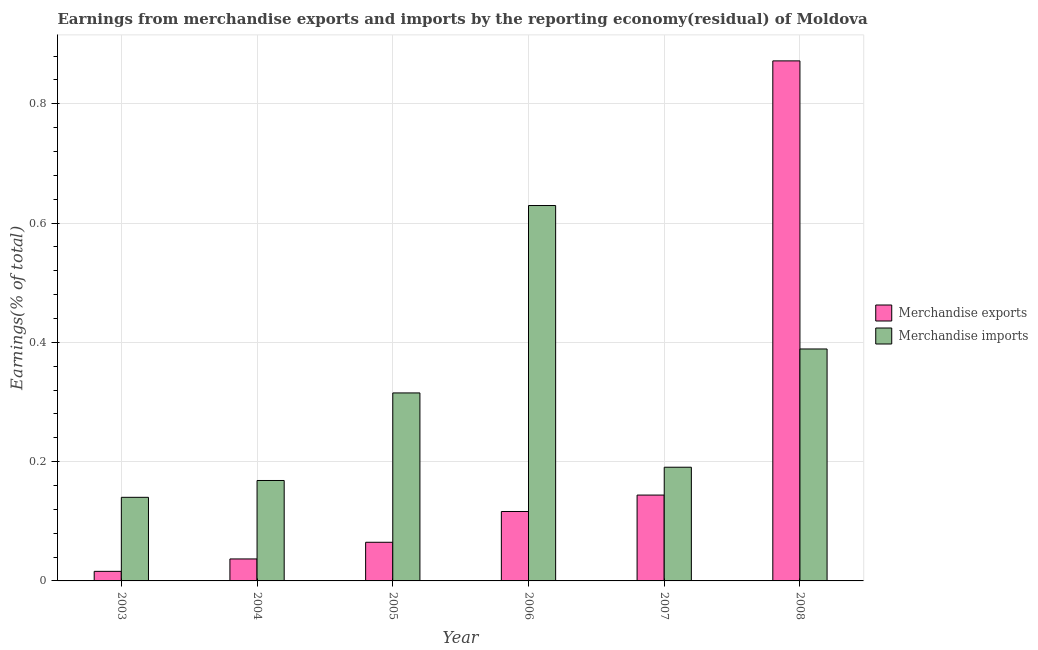Are the number of bars per tick equal to the number of legend labels?
Ensure brevity in your answer.  Yes. Are the number of bars on each tick of the X-axis equal?
Your response must be concise. Yes. What is the label of the 5th group of bars from the left?
Provide a short and direct response. 2007. In how many cases, is the number of bars for a given year not equal to the number of legend labels?
Offer a very short reply. 0. What is the earnings from merchandise imports in 2008?
Offer a very short reply. 0.39. Across all years, what is the maximum earnings from merchandise exports?
Offer a very short reply. 0.87. Across all years, what is the minimum earnings from merchandise imports?
Ensure brevity in your answer.  0.14. What is the total earnings from merchandise imports in the graph?
Provide a succinct answer. 1.83. What is the difference between the earnings from merchandise exports in 2004 and that in 2007?
Provide a short and direct response. -0.11. What is the difference between the earnings from merchandise exports in 2004 and the earnings from merchandise imports in 2008?
Your answer should be very brief. -0.84. What is the average earnings from merchandise exports per year?
Your answer should be compact. 0.21. In how many years, is the earnings from merchandise exports greater than 0.7200000000000001 %?
Make the answer very short. 1. What is the ratio of the earnings from merchandise exports in 2003 to that in 2007?
Ensure brevity in your answer.  0.11. Is the earnings from merchandise exports in 2004 less than that in 2008?
Your response must be concise. Yes. Is the difference between the earnings from merchandise imports in 2005 and 2007 greater than the difference between the earnings from merchandise exports in 2005 and 2007?
Your response must be concise. No. What is the difference between the highest and the second highest earnings from merchandise exports?
Give a very brief answer. 0.73. What is the difference between the highest and the lowest earnings from merchandise imports?
Offer a very short reply. 0.49. In how many years, is the earnings from merchandise exports greater than the average earnings from merchandise exports taken over all years?
Your answer should be very brief. 1. How many bars are there?
Provide a short and direct response. 12. Are all the bars in the graph horizontal?
Your answer should be compact. No. Are the values on the major ticks of Y-axis written in scientific E-notation?
Provide a succinct answer. No. Does the graph contain any zero values?
Make the answer very short. No. Does the graph contain grids?
Your answer should be very brief. Yes. Where does the legend appear in the graph?
Your response must be concise. Center right. What is the title of the graph?
Make the answer very short. Earnings from merchandise exports and imports by the reporting economy(residual) of Moldova. Does "Researchers" appear as one of the legend labels in the graph?
Keep it short and to the point. No. What is the label or title of the Y-axis?
Make the answer very short. Earnings(% of total). What is the Earnings(% of total) in Merchandise exports in 2003?
Offer a terse response. 0.02. What is the Earnings(% of total) of Merchandise imports in 2003?
Provide a short and direct response. 0.14. What is the Earnings(% of total) in Merchandise exports in 2004?
Provide a short and direct response. 0.04. What is the Earnings(% of total) in Merchandise imports in 2004?
Your answer should be compact. 0.17. What is the Earnings(% of total) in Merchandise exports in 2005?
Provide a succinct answer. 0.06. What is the Earnings(% of total) in Merchandise imports in 2005?
Offer a very short reply. 0.32. What is the Earnings(% of total) in Merchandise exports in 2006?
Keep it short and to the point. 0.12. What is the Earnings(% of total) in Merchandise imports in 2006?
Provide a succinct answer. 0.63. What is the Earnings(% of total) of Merchandise exports in 2007?
Your answer should be very brief. 0.14. What is the Earnings(% of total) of Merchandise imports in 2007?
Offer a terse response. 0.19. What is the Earnings(% of total) in Merchandise exports in 2008?
Make the answer very short. 0.87. What is the Earnings(% of total) in Merchandise imports in 2008?
Make the answer very short. 0.39. Across all years, what is the maximum Earnings(% of total) in Merchandise exports?
Keep it short and to the point. 0.87. Across all years, what is the maximum Earnings(% of total) of Merchandise imports?
Your response must be concise. 0.63. Across all years, what is the minimum Earnings(% of total) in Merchandise exports?
Provide a short and direct response. 0.02. Across all years, what is the minimum Earnings(% of total) of Merchandise imports?
Offer a very short reply. 0.14. What is the total Earnings(% of total) of Merchandise exports in the graph?
Offer a very short reply. 1.25. What is the total Earnings(% of total) of Merchandise imports in the graph?
Your response must be concise. 1.83. What is the difference between the Earnings(% of total) of Merchandise exports in 2003 and that in 2004?
Provide a succinct answer. -0.02. What is the difference between the Earnings(% of total) of Merchandise imports in 2003 and that in 2004?
Give a very brief answer. -0.03. What is the difference between the Earnings(% of total) of Merchandise exports in 2003 and that in 2005?
Your response must be concise. -0.05. What is the difference between the Earnings(% of total) of Merchandise imports in 2003 and that in 2005?
Offer a very short reply. -0.17. What is the difference between the Earnings(% of total) in Merchandise exports in 2003 and that in 2006?
Provide a succinct answer. -0.1. What is the difference between the Earnings(% of total) of Merchandise imports in 2003 and that in 2006?
Keep it short and to the point. -0.49. What is the difference between the Earnings(% of total) in Merchandise exports in 2003 and that in 2007?
Provide a short and direct response. -0.13. What is the difference between the Earnings(% of total) in Merchandise imports in 2003 and that in 2007?
Give a very brief answer. -0.05. What is the difference between the Earnings(% of total) in Merchandise exports in 2003 and that in 2008?
Provide a short and direct response. -0.86. What is the difference between the Earnings(% of total) of Merchandise imports in 2003 and that in 2008?
Your response must be concise. -0.25. What is the difference between the Earnings(% of total) in Merchandise exports in 2004 and that in 2005?
Provide a short and direct response. -0.03. What is the difference between the Earnings(% of total) of Merchandise imports in 2004 and that in 2005?
Provide a succinct answer. -0.15. What is the difference between the Earnings(% of total) in Merchandise exports in 2004 and that in 2006?
Make the answer very short. -0.08. What is the difference between the Earnings(% of total) of Merchandise imports in 2004 and that in 2006?
Make the answer very short. -0.46. What is the difference between the Earnings(% of total) in Merchandise exports in 2004 and that in 2007?
Give a very brief answer. -0.11. What is the difference between the Earnings(% of total) of Merchandise imports in 2004 and that in 2007?
Make the answer very short. -0.02. What is the difference between the Earnings(% of total) in Merchandise exports in 2004 and that in 2008?
Your response must be concise. -0.84. What is the difference between the Earnings(% of total) in Merchandise imports in 2004 and that in 2008?
Offer a very short reply. -0.22. What is the difference between the Earnings(% of total) in Merchandise exports in 2005 and that in 2006?
Provide a short and direct response. -0.05. What is the difference between the Earnings(% of total) in Merchandise imports in 2005 and that in 2006?
Give a very brief answer. -0.31. What is the difference between the Earnings(% of total) of Merchandise exports in 2005 and that in 2007?
Provide a short and direct response. -0.08. What is the difference between the Earnings(% of total) of Merchandise imports in 2005 and that in 2007?
Your answer should be very brief. 0.12. What is the difference between the Earnings(% of total) of Merchandise exports in 2005 and that in 2008?
Ensure brevity in your answer.  -0.81. What is the difference between the Earnings(% of total) in Merchandise imports in 2005 and that in 2008?
Provide a succinct answer. -0.07. What is the difference between the Earnings(% of total) in Merchandise exports in 2006 and that in 2007?
Your response must be concise. -0.03. What is the difference between the Earnings(% of total) of Merchandise imports in 2006 and that in 2007?
Your answer should be very brief. 0.44. What is the difference between the Earnings(% of total) in Merchandise exports in 2006 and that in 2008?
Offer a terse response. -0.76. What is the difference between the Earnings(% of total) in Merchandise imports in 2006 and that in 2008?
Your answer should be very brief. 0.24. What is the difference between the Earnings(% of total) of Merchandise exports in 2007 and that in 2008?
Your answer should be compact. -0.73. What is the difference between the Earnings(% of total) of Merchandise imports in 2007 and that in 2008?
Your answer should be compact. -0.2. What is the difference between the Earnings(% of total) of Merchandise exports in 2003 and the Earnings(% of total) of Merchandise imports in 2004?
Provide a succinct answer. -0.15. What is the difference between the Earnings(% of total) of Merchandise exports in 2003 and the Earnings(% of total) of Merchandise imports in 2005?
Ensure brevity in your answer.  -0.3. What is the difference between the Earnings(% of total) in Merchandise exports in 2003 and the Earnings(% of total) in Merchandise imports in 2006?
Your answer should be compact. -0.61. What is the difference between the Earnings(% of total) in Merchandise exports in 2003 and the Earnings(% of total) in Merchandise imports in 2007?
Ensure brevity in your answer.  -0.17. What is the difference between the Earnings(% of total) in Merchandise exports in 2003 and the Earnings(% of total) in Merchandise imports in 2008?
Ensure brevity in your answer.  -0.37. What is the difference between the Earnings(% of total) of Merchandise exports in 2004 and the Earnings(% of total) of Merchandise imports in 2005?
Ensure brevity in your answer.  -0.28. What is the difference between the Earnings(% of total) in Merchandise exports in 2004 and the Earnings(% of total) in Merchandise imports in 2006?
Offer a very short reply. -0.59. What is the difference between the Earnings(% of total) in Merchandise exports in 2004 and the Earnings(% of total) in Merchandise imports in 2007?
Keep it short and to the point. -0.15. What is the difference between the Earnings(% of total) in Merchandise exports in 2004 and the Earnings(% of total) in Merchandise imports in 2008?
Ensure brevity in your answer.  -0.35. What is the difference between the Earnings(% of total) in Merchandise exports in 2005 and the Earnings(% of total) in Merchandise imports in 2006?
Your answer should be compact. -0.56. What is the difference between the Earnings(% of total) of Merchandise exports in 2005 and the Earnings(% of total) of Merchandise imports in 2007?
Keep it short and to the point. -0.13. What is the difference between the Earnings(% of total) in Merchandise exports in 2005 and the Earnings(% of total) in Merchandise imports in 2008?
Your response must be concise. -0.32. What is the difference between the Earnings(% of total) of Merchandise exports in 2006 and the Earnings(% of total) of Merchandise imports in 2007?
Make the answer very short. -0.07. What is the difference between the Earnings(% of total) in Merchandise exports in 2006 and the Earnings(% of total) in Merchandise imports in 2008?
Provide a succinct answer. -0.27. What is the difference between the Earnings(% of total) of Merchandise exports in 2007 and the Earnings(% of total) of Merchandise imports in 2008?
Your answer should be compact. -0.24. What is the average Earnings(% of total) of Merchandise exports per year?
Provide a succinct answer. 0.21. What is the average Earnings(% of total) of Merchandise imports per year?
Offer a very short reply. 0.31. In the year 2003, what is the difference between the Earnings(% of total) in Merchandise exports and Earnings(% of total) in Merchandise imports?
Give a very brief answer. -0.12. In the year 2004, what is the difference between the Earnings(% of total) of Merchandise exports and Earnings(% of total) of Merchandise imports?
Offer a very short reply. -0.13. In the year 2005, what is the difference between the Earnings(% of total) in Merchandise exports and Earnings(% of total) in Merchandise imports?
Your answer should be very brief. -0.25. In the year 2006, what is the difference between the Earnings(% of total) of Merchandise exports and Earnings(% of total) of Merchandise imports?
Keep it short and to the point. -0.51. In the year 2007, what is the difference between the Earnings(% of total) of Merchandise exports and Earnings(% of total) of Merchandise imports?
Provide a succinct answer. -0.05. In the year 2008, what is the difference between the Earnings(% of total) of Merchandise exports and Earnings(% of total) of Merchandise imports?
Offer a terse response. 0.48. What is the ratio of the Earnings(% of total) of Merchandise exports in 2003 to that in 2004?
Ensure brevity in your answer.  0.44. What is the ratio of the Earnings(% of total) in Merchandise imports in 2003 to that in 2004?
Your response must be concise. 0.83. What is the ratio of the Earnings(% of total) in Merchandise exports in 2003 to that in 2005?
Your response must be concise. 0.25. What is the ratio of the Earnings(% of total) in Merchandise imports in 2003 to that in 2005?
Your response must be concise. 0.44. What is the ratio of the Earnings(% of total) of Merchandise exports in 2003 to that in 2006?
Your answer should be compact. 0.14. What is the ratio of the Earnings(% of total) in Merchandise imports in 2003 to that in 2006?
Provide a short and direct response. 0.22. What is the ratio of the Earnings(% of total) in Merchandise exports in 2003 to that in 2007?
Offer a very short reply. 0.11. What is the ratio of the Earnings(% of total) in Merchandise imports in 2003 to that in 2007?
Offer a very short reply. 0.74. What is the ratio of the Earnings(% of total) in Merchandise exports in 2003 to that in 2008?
Your answer should be very brief. 0.02. What is the ratio of the Earnings(% of total) in Merchandise imports in 2003 to that in 2008?
Your response must be concise. 0.36. What is the ratio of the Earnings(% of total) in Merchandise exports in 2004 to that in 2005?
Provide a succinct answer. 0.57. What is the ratio of the Earnings(% of total) of Merchandise imports in 2004 to that in 2005?
Ensure brevity in your answer.  0.53. What is the ratio of the Earnings(% of total) of Merchandise exports in 2004 to that in 2006?
Offer a very short reply. 0.32. What is the ratio of the Earnings(% of total) in Merchandise imports in 2004 to that in 2006?
Ensure brevity in your answer.  0.27. What is the ratio of the Earnings(% of total) of Merchandise exports in 2004 to that in 2007?
Ensure brevity in your answer.  0.26. What is the ratio of the Earnings(% of total) of Merchandise imports in 2004 to that in 2007?
Offer a very short reply. 0.88. What is the ratio of the Earnings(% of total) in Merchandise exports in 2004 to that in 2008?
Your response must be concise. 0.04. What is the ratio of the Earnings(% of total) in Merchandise imports in 2004 to that in 2008?
Offer a very short reply. 0.43. What is the ratio of the Earnings(% of total) of Merchandise exports in 2005 to that in 2006?
Provide a short and direct response. 0.56. What is the ratio of the Earnings(% of total) of Merchandise imports in 2005 to that in 2006?
Offer a very short reply. 0.5. What is the ratio of the Earnings(% of total) in Merchandise exports in 2005 to that in 2007?
Give a very brief answer. 0.45. What is the ratio of the Earnings(% of total) of Merchandise imports in 2005 to that in 2007?
Offer a terse response. 1.65. What is the ratio of the Earnings(% of total) in Merchandise exports in 2005 to that in 2008?
Offer a very short reply. 0.07. What is the ratio of the Earnings(% of total) in Merchandise imports in 2005 to that in 2008?
Keep it short and to the point. 0.81. What is the ratio of the Earnings(% of total) in Merchandise exports in 2006 to that in 2007?
Give a very brief answer. 0.81. What is the ratio of the Earnings(% of total) of Merchandise imports in 2006 to that in 2007?
Offer a terse response. 3.3. What is the ratio of the Earnings(% of total) of Merchandise exports in 2006 to that in 2008?
Give a very brief answer. 0.13. What is the ratio of the Earnings(% of total) of Merchandise imports in 2006 to that in 2008?
Provide a short and direct response. 1.62. What is the ratio of the Earnings(% of total) in Merchandise exports in 2007 to that in 2008?
Ensure brevity in your answer.  0.17. What is the ratio of the Earnings(% of total) of Merchandise imports in 2007 to that in 2008?
Your answer should be compact. 0.49. What is the difference between the highest and the second highest Earnings(% of total) in Merchandise exports?
Keep it short and to the point. 0.73. What is the difference between the highest and the second highest Earnings(% of total) in Merchandise imports?
Give a very brief answer. 0.24. What is the difference between the highest and the lowest Earnings(% of total) of Merchandise exports?
Offer a very short reply. 0.86. What is the difference between the highest and the lowest Earnings(% of total) of Merchandise imports?
Your answer should be compact. 0.49. 